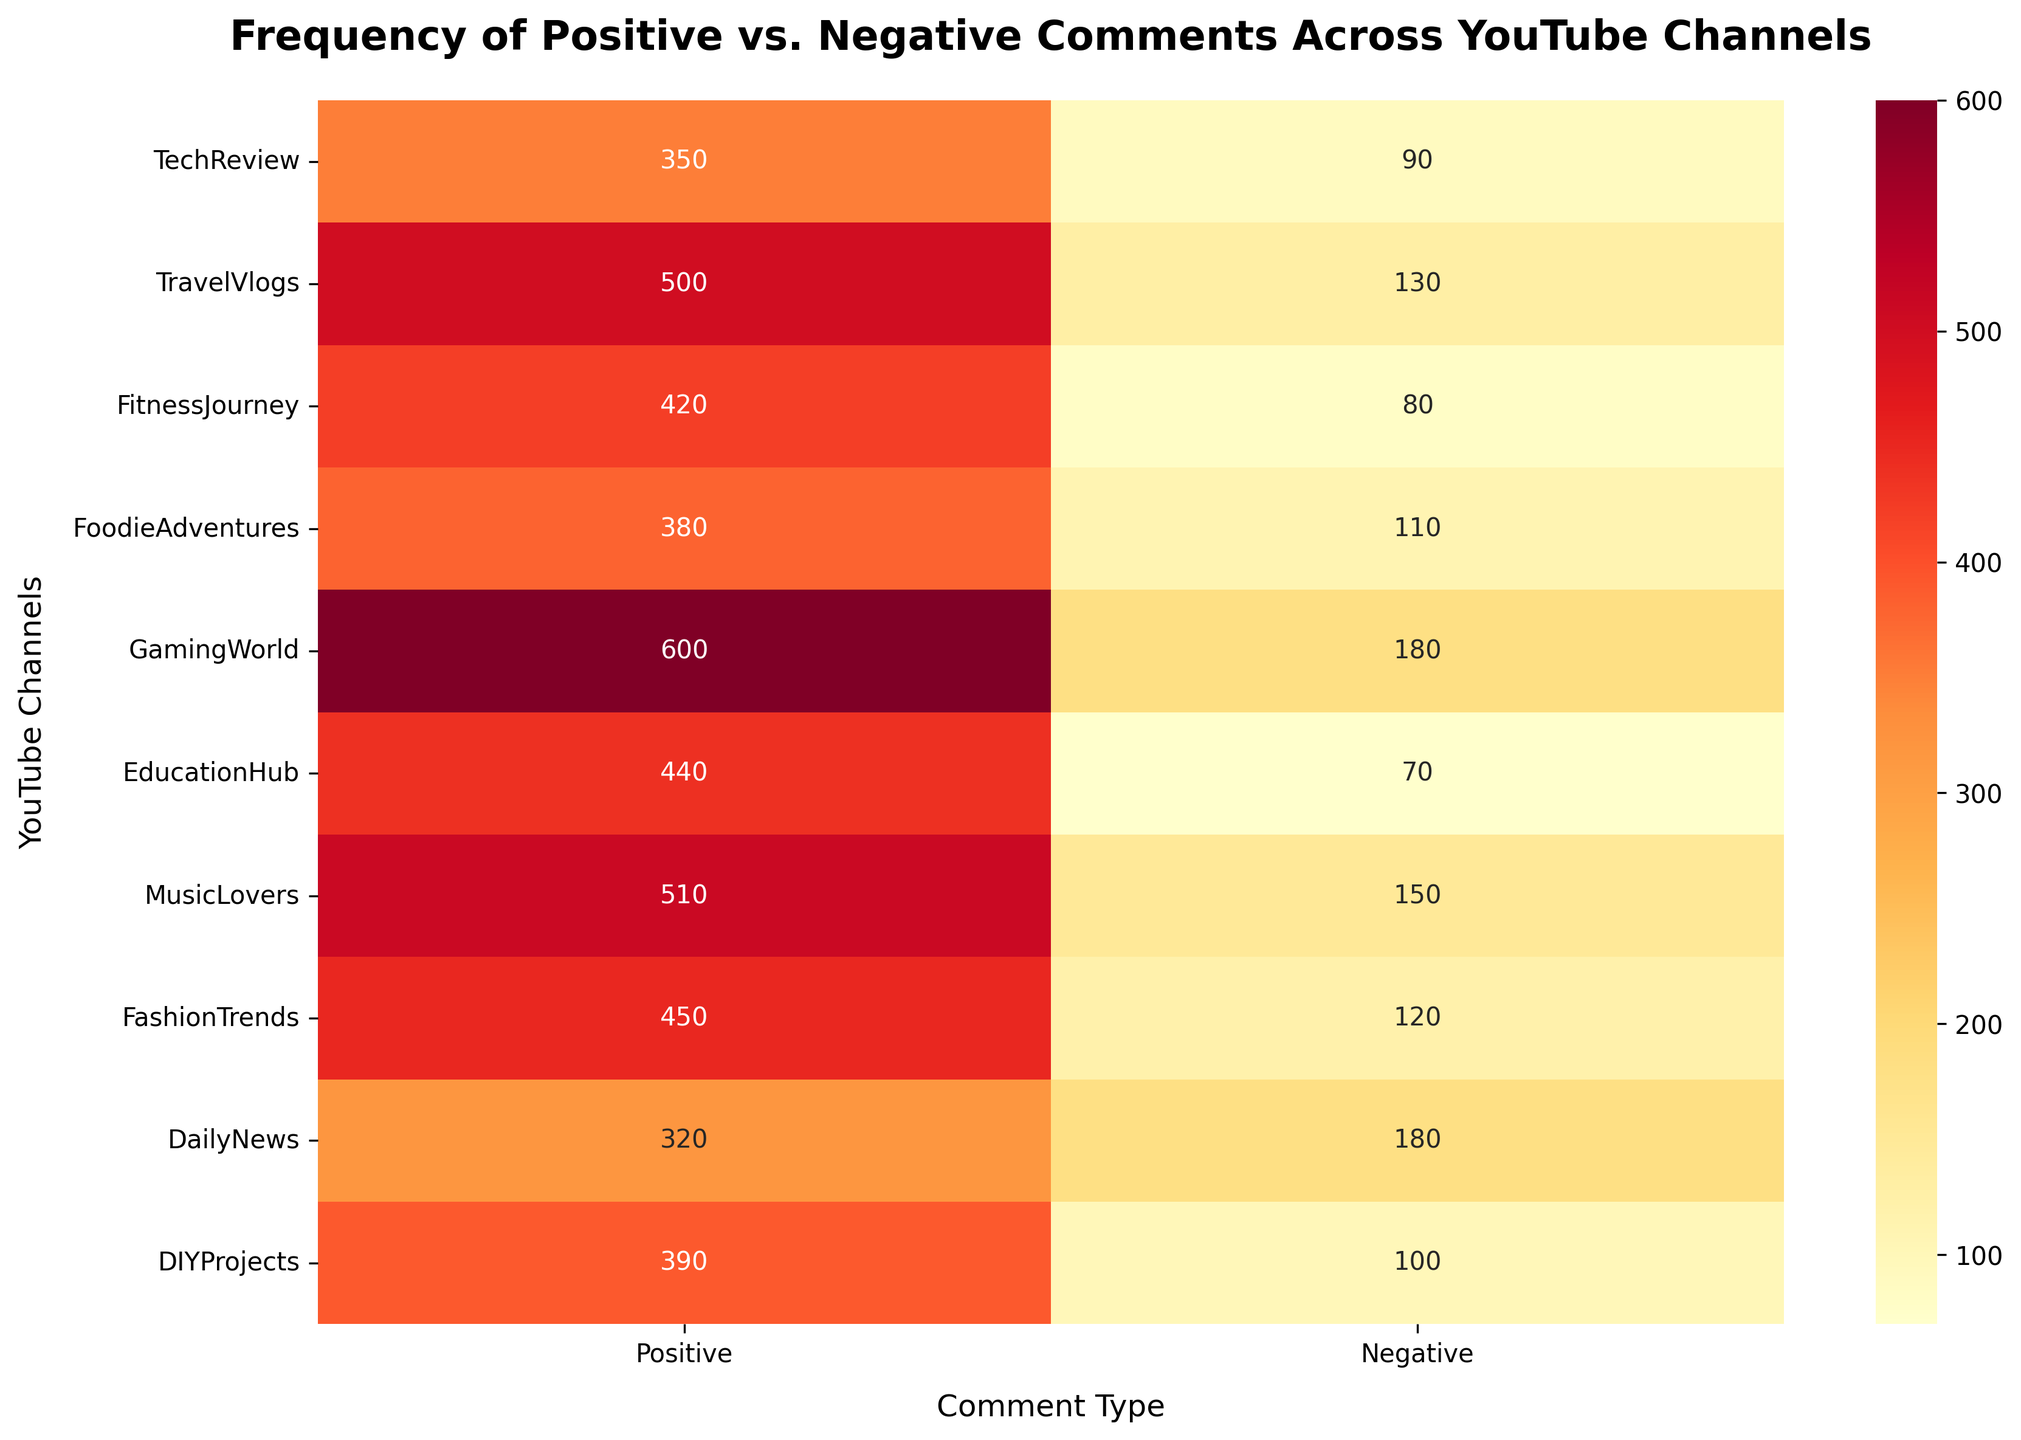What is the title of the heatmap? The title of the heatmap can be found at the top of the figure.
Answer: Frequency of Positive vs. Negative Comments Across YouTube Channels Which channel has the highest number of positive comments? By looking at the heatmap, identify the channel with the largest number annotated under the 'Positive' column.
Answer: GamingWorld What is the total number of negative comments across all channels? Sum the numbers in the 'Negative' column across all rows. (90 + 130 + 80 + 110 + 180 + 70 + 150 + 120 + 180 + 100 = 1210)
Answer: 1210 Which channel shows a greater number of positive comments compared to negative comments? Compare the numbers under 'Positive' and 'Negative' for each channel and identify where the positive number is higher.
Answer: TechReview, TravelVlogs, FitnessJourney, FoodieAdventures, EducationHub, MusicLovers, FashionTrends, DIYProjects Which channel has the smallest gap between positive and negative comments? Calculate the difference between positive and negative comments for each channel and identify the smallest gap. (E.g., for DIYProjects: 390 - 100 = 290)
Answer: FitnessJourney What is the average number of positive comments per channel? Sum all positive comments and divide by the number of channels. (350 + 500 + 420 + 380 + 600 + 440 + 510 + 450 + 320 + 390) / 10 = 436
Answer: 436 Which two channels have the same number of negative comments? Look through the heatmap to find channels with the same value in the 'Negative' column.
Answer: DailyNews and GamingWorld What is the total number of comments (positive + negative) for the channel with the most positive comments? Identify the channel with the most positive comments, then sum both positive and negative numbers for that channel. (GamingWorld: 600 + 180 = 780)
Answer: 780 Which channels have more than 500 positive comments? Identify channels with a number greater than 500 in the 'Positive' column by inspecting the heatmap.
Answer: TravelVlogs, GamingWorld, MusicLovers If we were to highlight the channel with the most comments overall, which one would it be? Sum the positive and negative comments for each channel and find the one with the highest total. (GamingWorld: 600 + 180 = 780 is the highest)
Answer: GamingWorld 